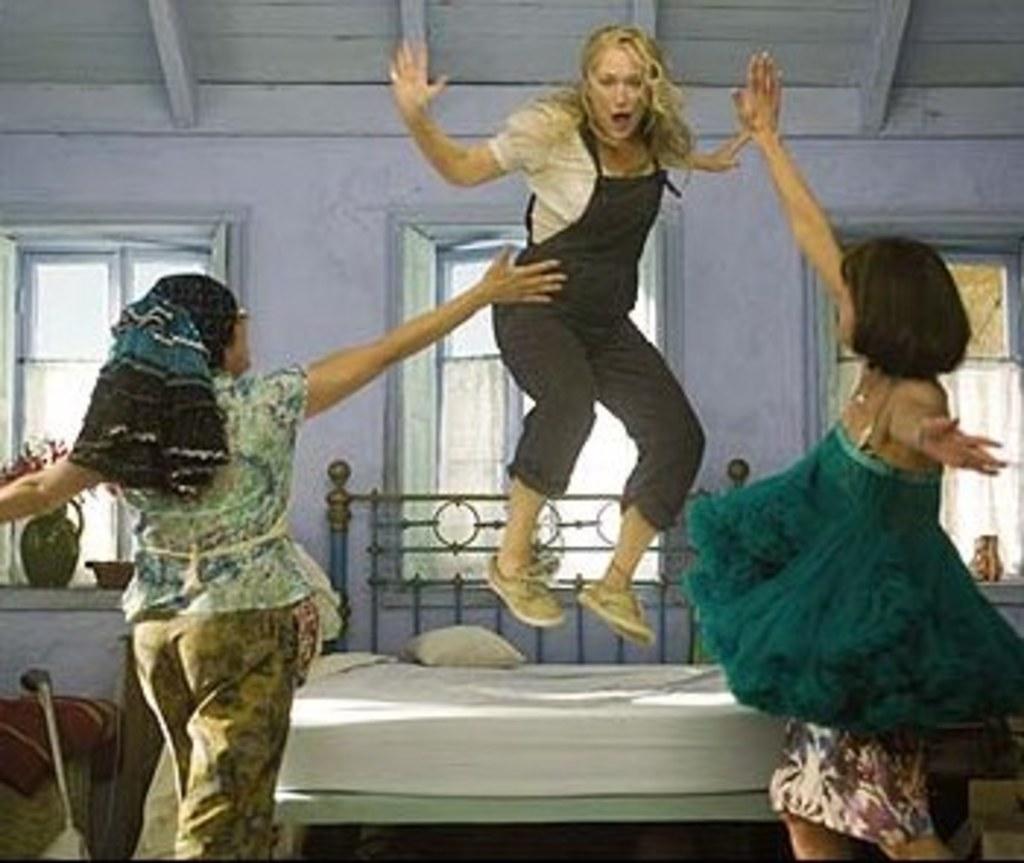Describe this image in one or two sentences. In front of the image there are two women. In front of them there is a woman jumping in the air, behind the woman there is a metal rod bed with mattress and a pillow on it. Besides the bed there are some objects on the floor, behind the bed there are glass windows with curtains on it. On the platform of the windows there are some objects. At the top of the image there is a wooden rooftop. 